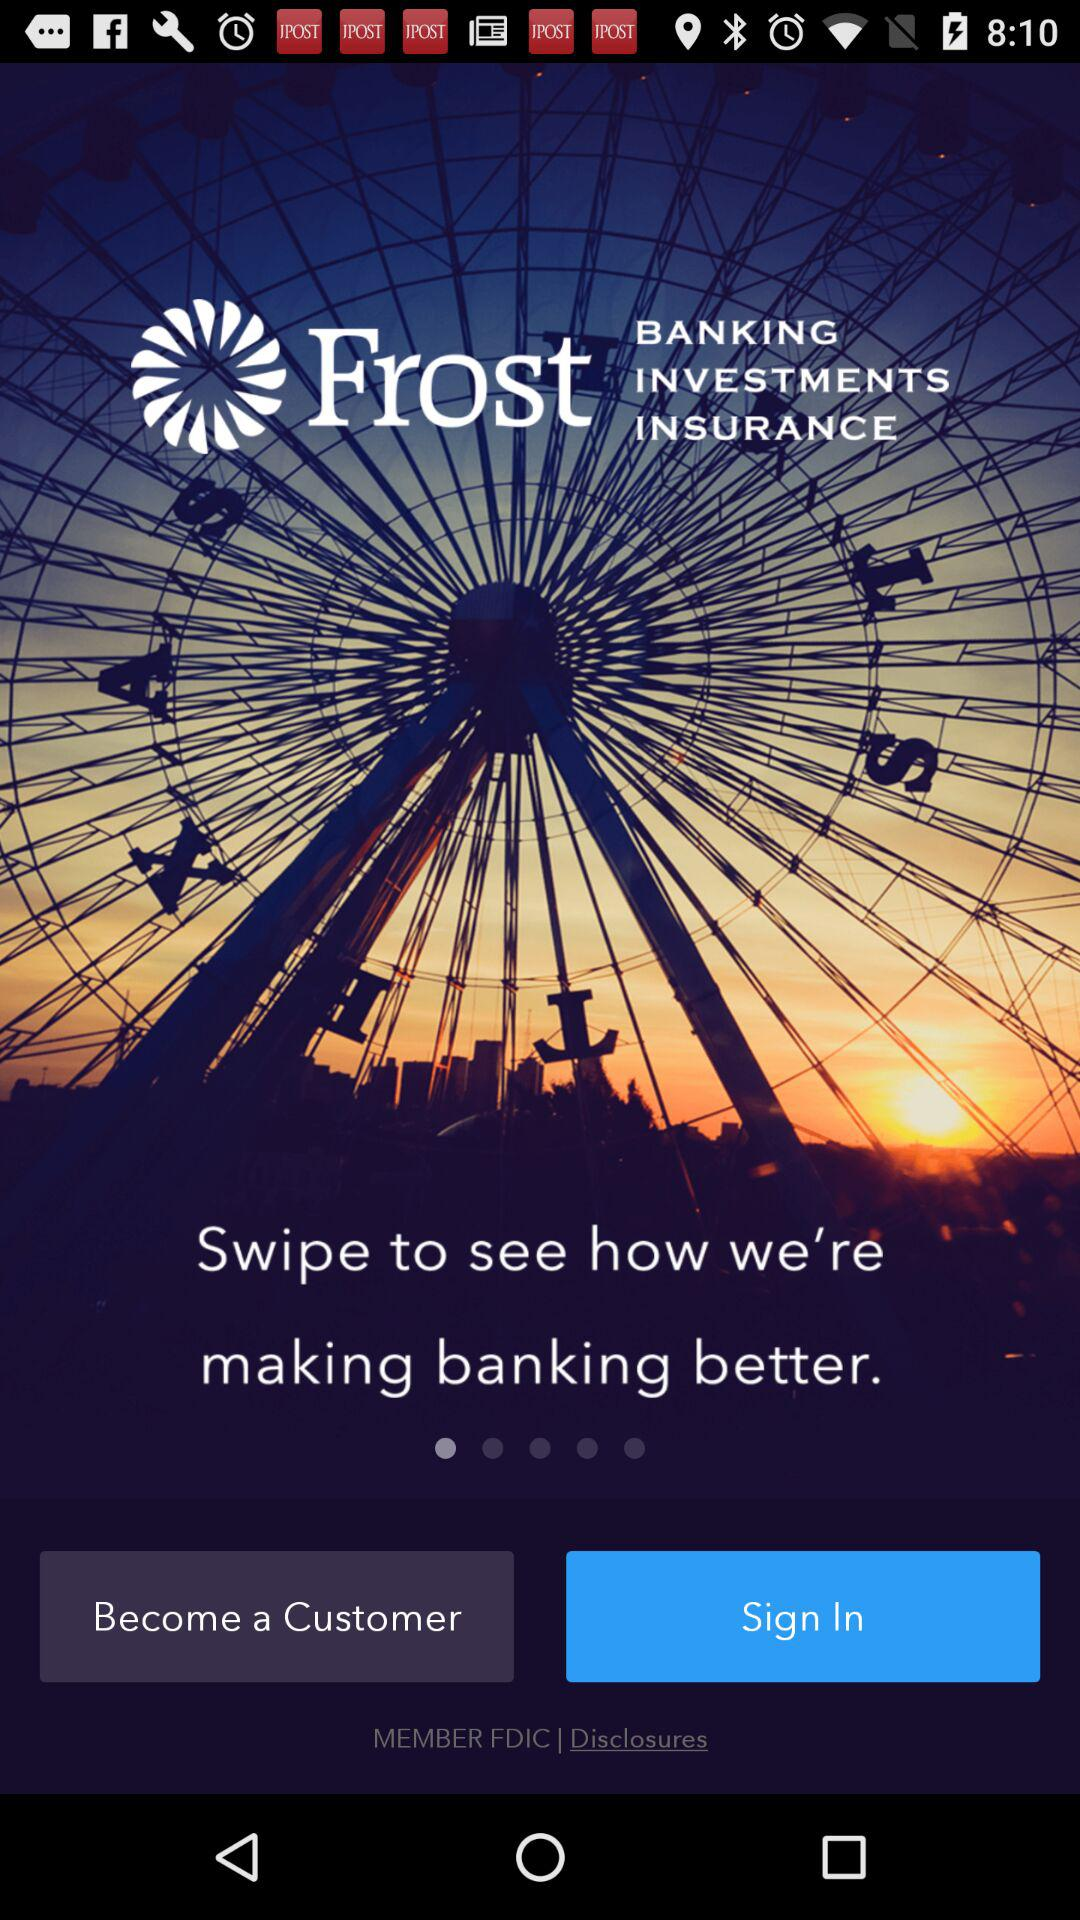What is the name of the application? The name of the application is "Frost". 